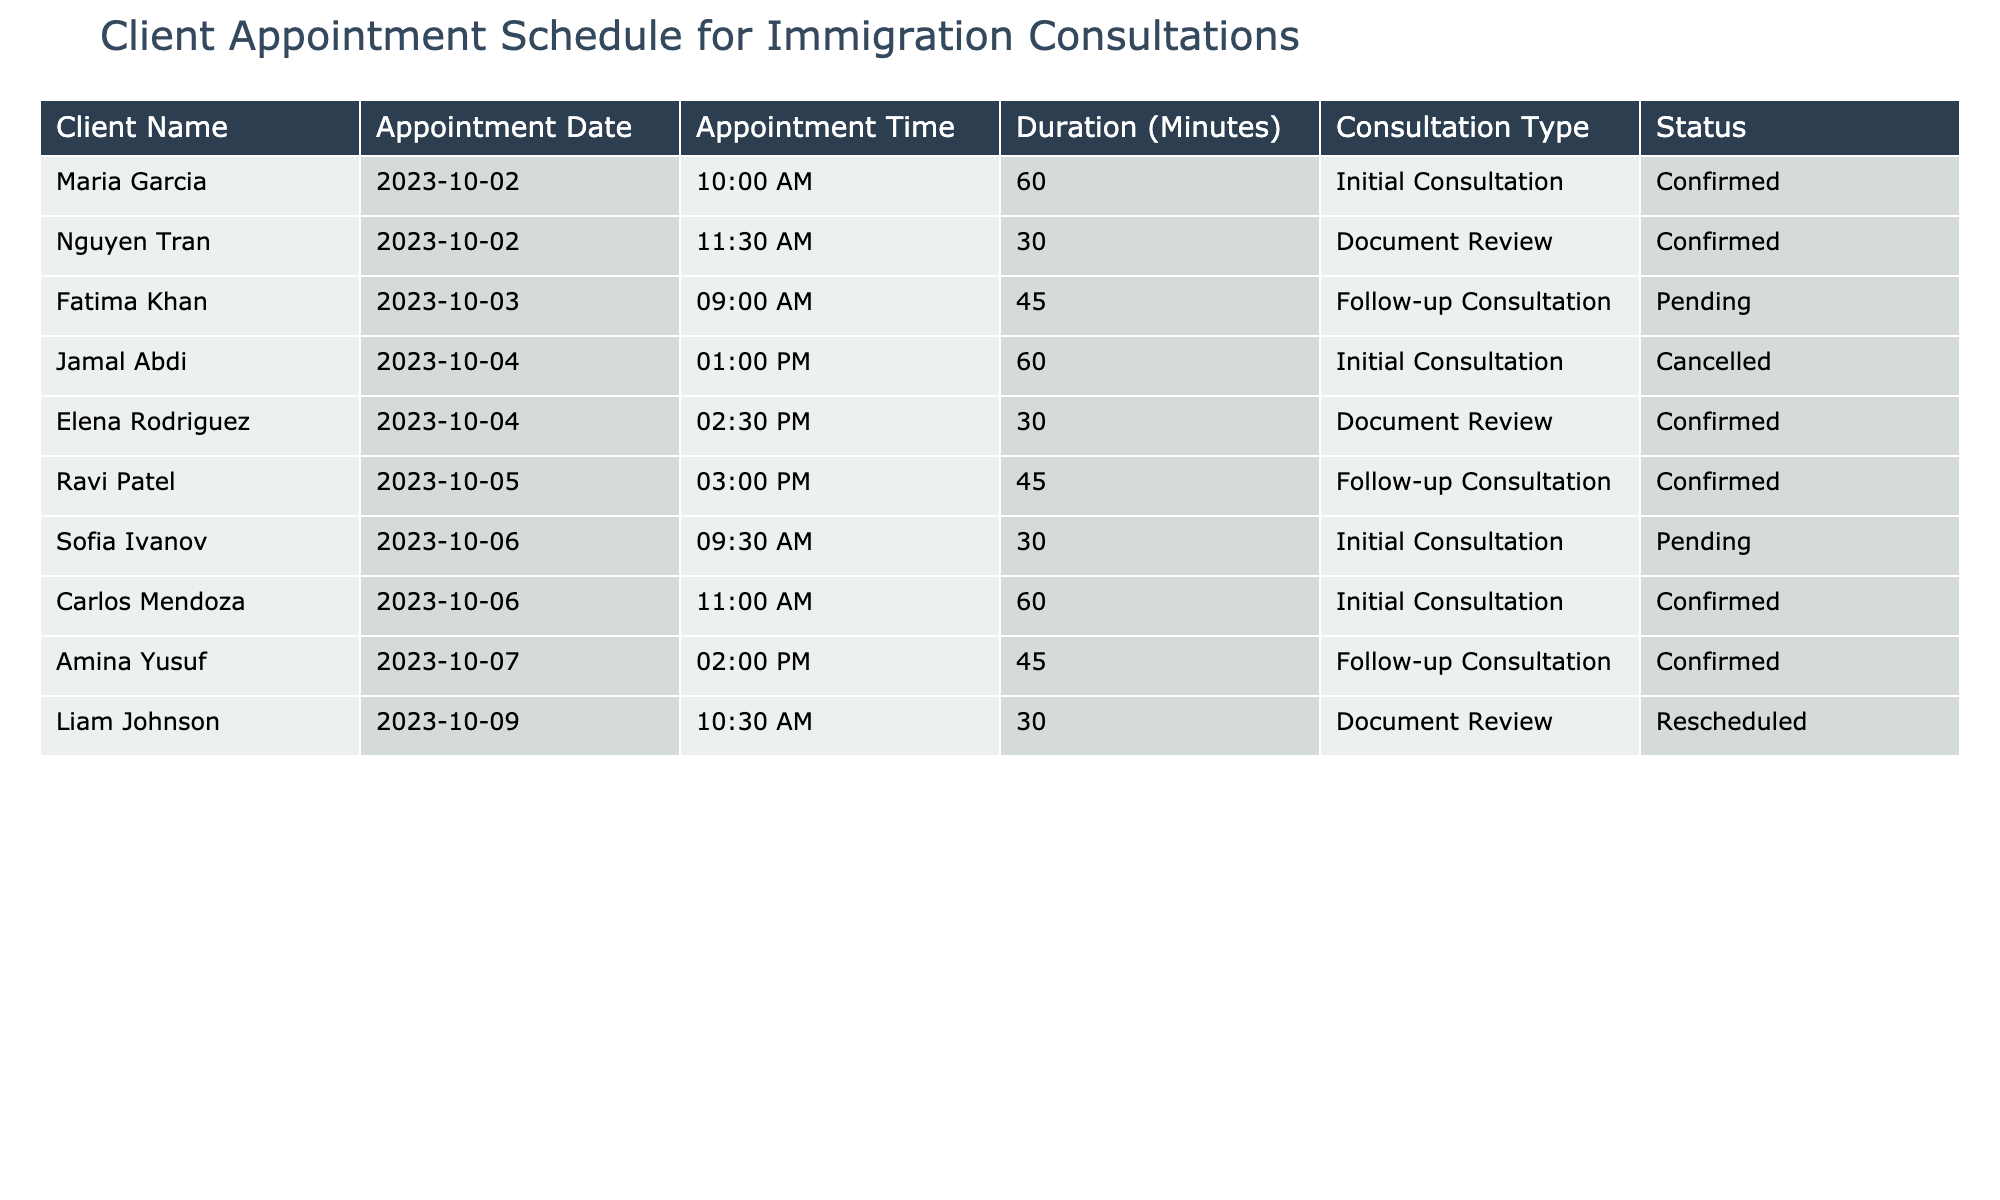What is the appointment time for Amina Yusuf? Looking at the table, I find Amina Yusuf listed under the Client Name column. The corresponding Appointment Time next to her name is 02:00 PM.
Answer: 02:00 PM How many clients have a confirmed status? I count the status column for any instance of "Confirmed." There are four clients—Maria Garcia, Elena Rodriguez, Carlos Mendoza, and Amina Yusuf—who have this status.
Answer: 4 What is the average duration of all the consultations listed? I first identify all the durations in the table, which are 60, 30, 45, 60, 30, 45, 60, and 45 minutes. Next, I sum these values: (60 + 30 + 45 + 60 + 30 + 45 + 60 + 45) = 375 minutes. There are 8 clients, so the average duration is 375/8 = 46.875 minutes, which can be rounded to 47 minutes.
Answer: 47 Is there a consultation type scheduled for October 4? To answer this, I look for the 'Appointment Date' of October 4 in the table. I find two consultations: one for Jamal Abdi and one for Elena Rodriguez. Therefore, yes, there are consultations scheduled for that date.
Answer: Yes Which consultation type has the highest number of clients? First, I count the occurrences of each consultation type in the table. The counts are: Initial Consultation (4), Document Review (3), and Follow-up Consultation (3). The Initial Consultation has the highest number at 4 clients.
Answer: Initial Consultation 